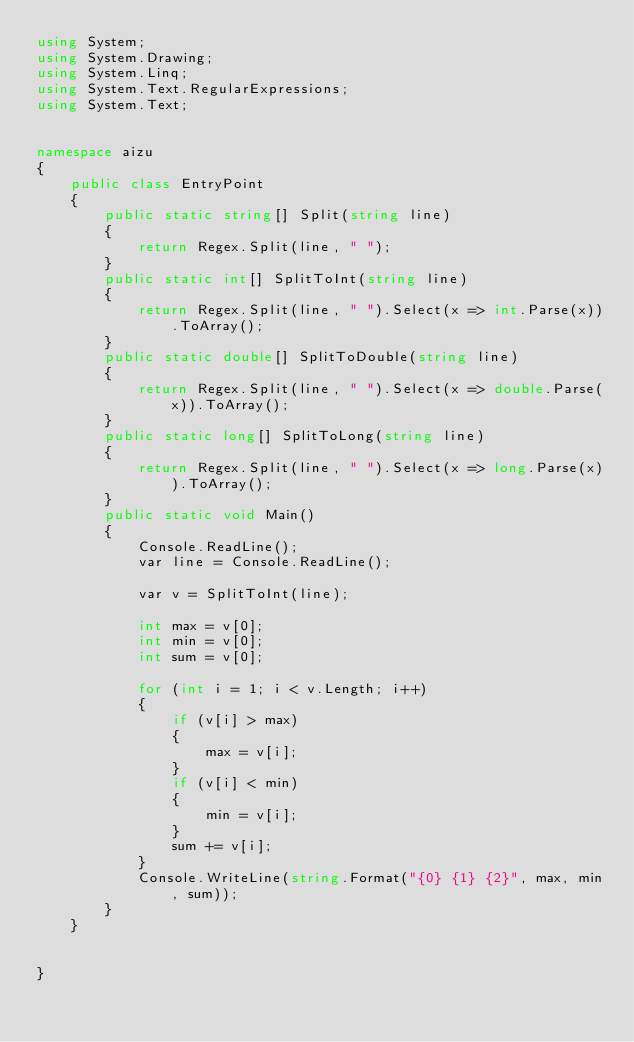<code> <loc_0><loc_0><loc_500><loc_500><_C#_>using System;
using System.Drawing;
using System.Linq;
using System.Text.RegularExpressions;
using System.Text;


namespace aizu
{
	public class EntryPoint
	{
		public static string[] Split(string line)
		{
			return Regex.Split(line, " ");
		}
		public static int[] SplitToInt(string line)
		{
			return Regex.Split(line, " ").Select(x => int.Parse(x)).ToArray();
		}
		public static double[] SplitToDouble(string line)
		{
			return Regex.Split(line, " ").Select(x => double.Parse(x)).ToArray();
		}
		public static long[] SplitToLong(string line)
		{
			return Regex.Split(line, " ").Select(x => long.Parse(x)).ToArray();
		}
		public static void Main()
		{
			Console.ReadLine();
			var line = Console.ReadLine();
			
			var v = SplitToInt(line);
			
			int max = v[0];
			int min = v[0];
			int sum = v[0];
			
			for (int i = 1; i < v.Length; i++)
			{
				if (v[i] > max)
				{
					max = v[i];
				}
				if (v[i] < min)
				{
					min = v[i];
				}
				sum += v[i];
			}
			Console.WriteLine(string.Format("{0} {1} {2}", max, min, sum));
		}
	}


}</code> 